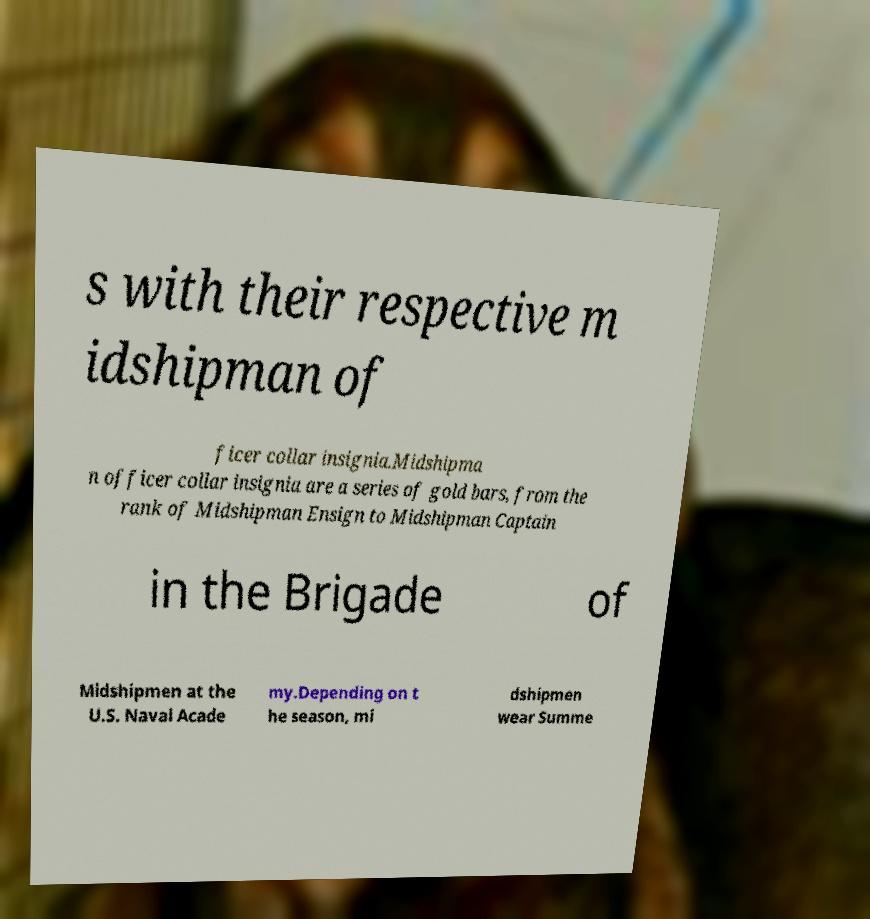I need the written content from this picture converted into text. Can you do that? s with their respective m idshipman of ficer collar insignia.Midshipma n officer collar insignia are a series of gold bars, from the rank of Midshipman Ensign to Midshipman Captain in the Brigade of Midshipmen at the U.S. Naval Acade my.Depending on t he season, mi dshipmen wear Summe 